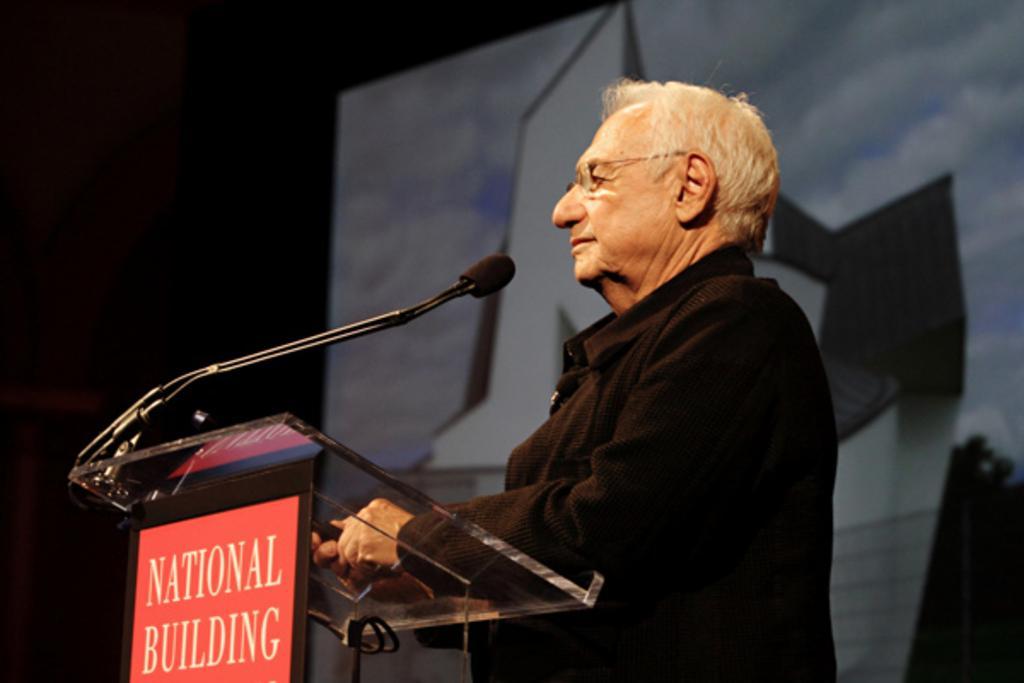Describe this image in one or two sentences. In the center of this picture we can see a person wearing black color dress and standing and holding same object. On the left we can see a microphone is attached to the podium and we can see the text on the podium. In the background we can see some other objects. 